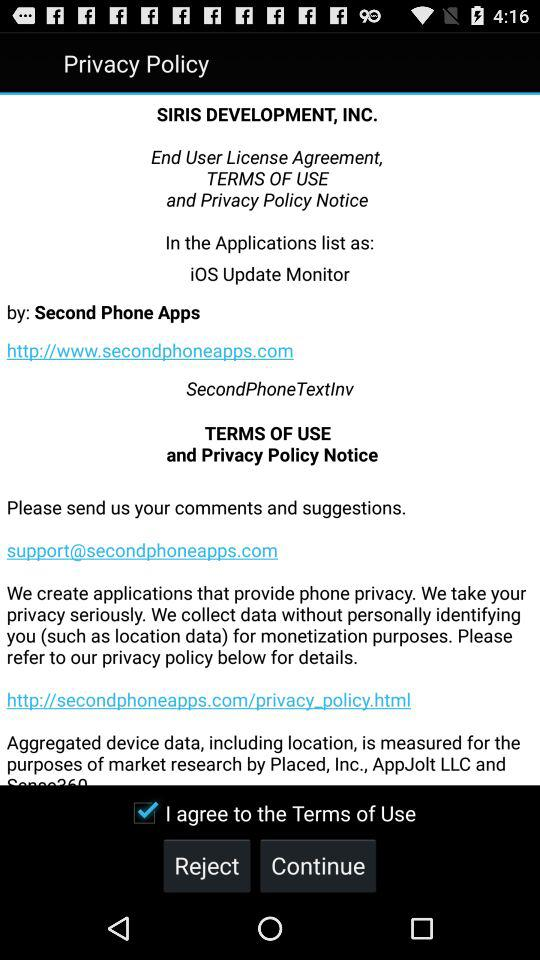What is the URL for the application's privacy policy? The URL for the application's privacy policy is http://secondphoneapps.com/privacy_policy.html. 